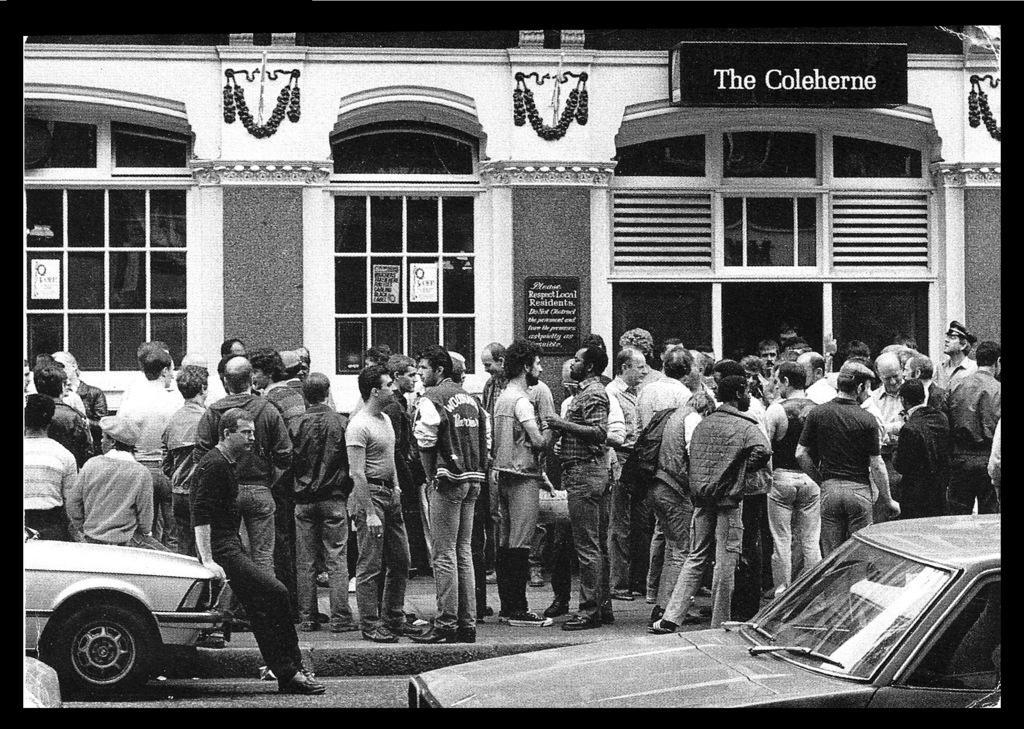How would you summarize this image in a sentence or two? This is a black and white image. In this image we can see there are a few people standing in front of the building and there are two cars on the road. 